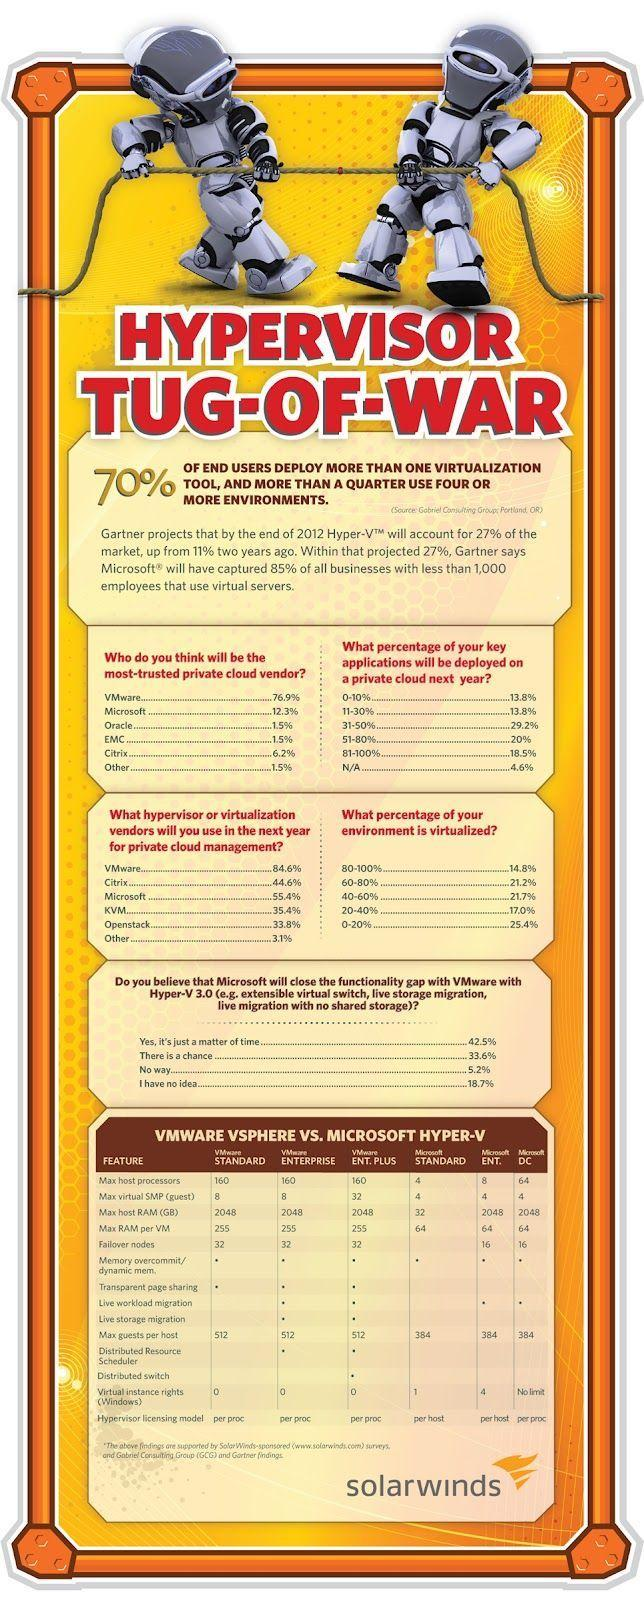To which VMware highest no of guest machines can be connected?
Answer the question with a short phrase. VMware ENT.PLUS Which virtual machine monitor has the fifth rank in future private cloud management? Openstack How many Microsoft Hyper-Vs have Failover nodes equal to 16? 2 In which Microsoft Hyper-V minimum no of host processors can be connected? Microsoft Standard How many different types of Microsoft Hyper-Vs are listed in the infographic? 3 Which virtual machine monitor has the third rank in future private cloud management? Citrix Which virtual machine monitor has the second rank in future private cloud management? Microsoft For how many VMware's maximum no of host processors can be 160? 3 